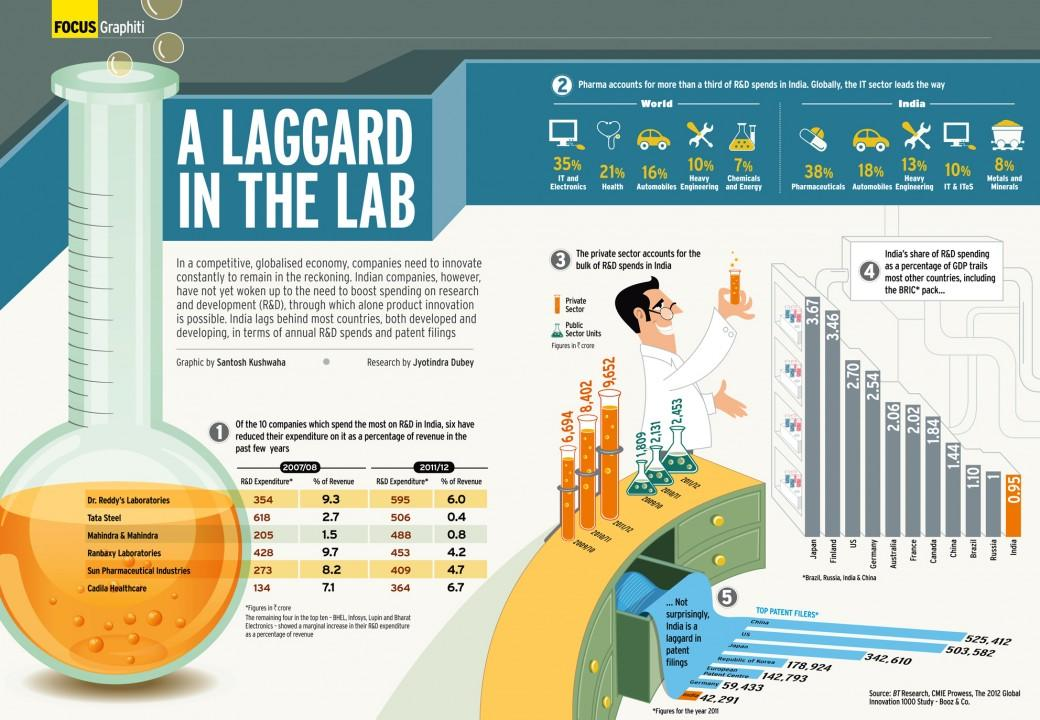Mention a couple of crucial points in this snapshot. The combined percentage of health and automobiles in the world is 37%. According to recent estimates, approximately 16% of the world's vehicles are automobiles. In 2007 and 2011 combined, Tata Steel's revenue was 3.1% of its total revenue. According to recent statistics, approximately 18% of the vehicles on the roads in India are automobiles. 